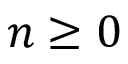Convert formula to latex. <formula><loc_0><loc_0><loc_500><loc_500>n \geq 0</formula> 